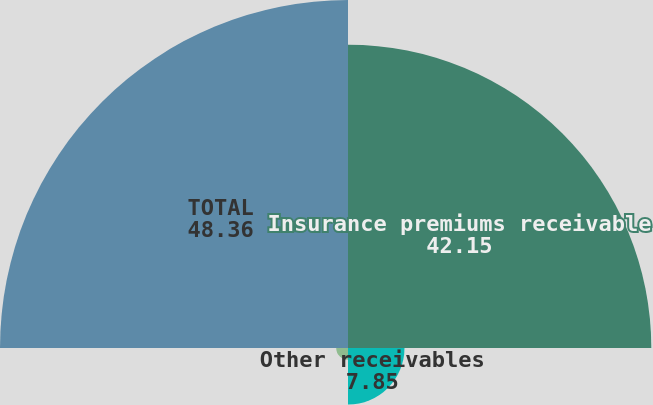Convert chart. <chart><loc_0><loc_0><loc_500><loc_500><pie_chart><fcel>Insurance premiums receivable<fcel>Other receivables<fcel>Allowance for uncollectible<fcel>TOTAL<nl><fcel>42.15%<fcel>7.85%<fcel>1.64%<fcel>48.36%<nl></chart> 